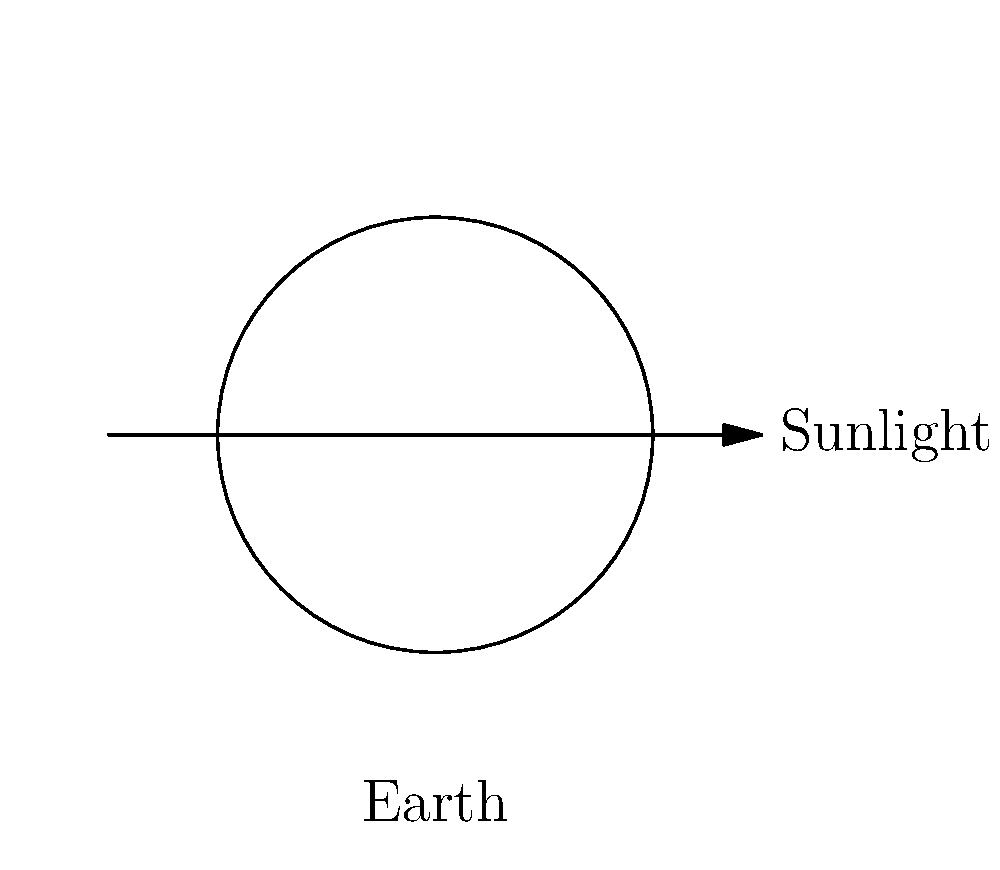As a voice actor collaborating with an anime enthusiast on a YouTube channel, you're asked to narrate a segment about lunar phases. The image shows different phases of the Moon as seen from Earth. Which phase is represented when the Moon appears as a complete circle of light in the night sky? To answer this question, let's analyze the lunar phases step-by-step:

1. The Moon's phases are caused by the changing relative positions of the Earth, Moon, and Sun.

2. The image shows the Moon's orbit around Earth, with sunlight coming from the right side.

3. The white part of each Moon representation is the illuminated portion visible from Earth.

4. As we move counterclockwise in the diagram:
   a) The new moon is not visible (completely dark).
   b) The crescent moon shows a small sliver of light.
   c) The first quarter moon is half illuminated.
   d) The gibbous moon is more than half illuminated.
   e) The full moon appears as a complete circle of light.

5. The full moon occurs when the Earth is between the Sun and the Moon, allowing us to see the entire illuminated face of the Moon.

6. In the diagram, this corresponds to the leftmost position, where the entire circular face of the Moon is white.

Therefore, when the Moon appears as a complete circle of light in the night sky, it is in the full moon phase.
Answer: Full moon 